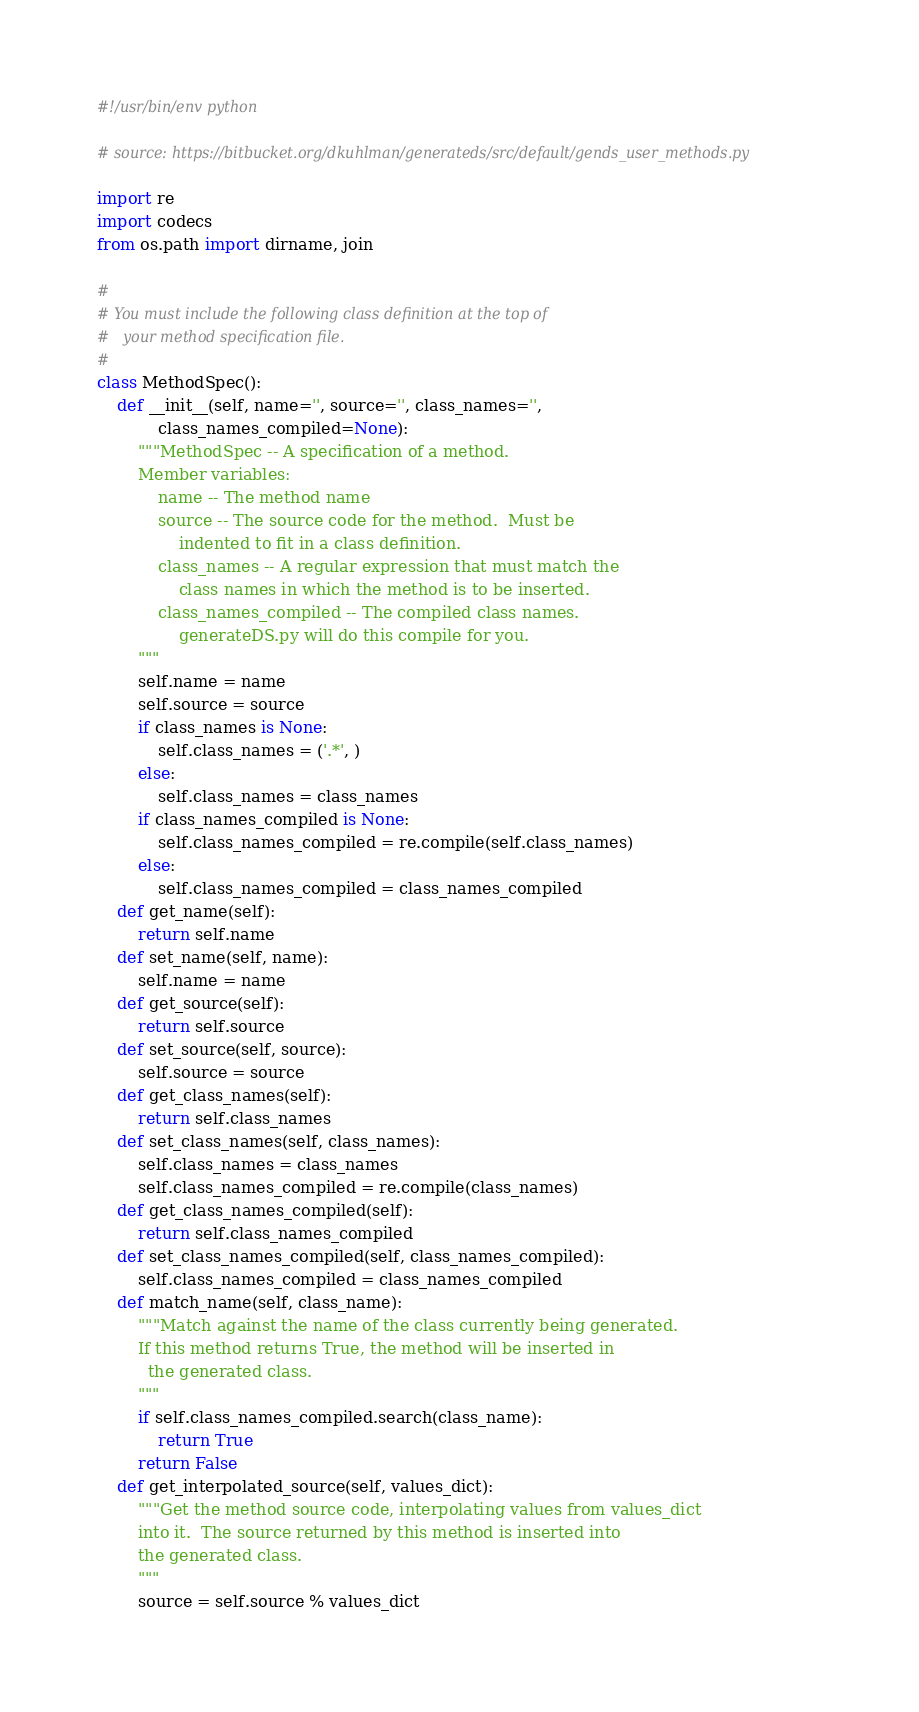<code> <loc_0><loc_0><loc_500><loc_500><_Python_>#!/usr/bin/env python

# source: https://bitbucket.org/dkuhlman/generateds/src/default/gends_user_methods.py

import re
import codecs
from os.path import dirname, join

#
# You must include the following class definition at the top of
#   your method specification file.
#
class MethodSpec():
    def __init__(self, name='', source='', class_names='',
            class_names_compiled=None):
        """MethodSpec -- A specification of a method.
        Member variables:
            name -- The method name
            source -- The source code for the method.  Must be
                indented to fit in a class definition.
            class_names -- A regular expression that must match the
                class names in which the method is to be inserted.
            class_names_compiled -- The compiled class names.
                generateDS.py will do this compile for you.
        """
        self.name = name
        self.source = source
        if class_names is None:
            self.class_names = ('.*', )
        else:
            self.class_names = class_names
        if class_names_compiled is None:
            self.class_names_compiled = re.compile(self.class_names)
        else:
            self.class_names_compiled = class_names_compiled
    def get_name(self):
        return self.name
    def set_name(self, name):
        self.name = name
    def get_source(self):
        return self.source
    def set_source(self, source):
        self.source = source
    def get_class_names(self):
        return self.class_names
    def set_class_names(self, class_names):
        self.class_names = class_names
        self.class_names_compiled = re.compile(class_names)
    def get_class_names_compiled(self):
        return self.class_names_compiled
    def set_class_names_compiled(self, class_names_compiled):
        self.class_names_compiled = class_names_compiled
    def match_name(self, class_name):
        """Match against the name of the class currently being generated.
        If this method returns True, the method will be inserted in
          the generated class.
        """
        if self.class_names_compiled.search(class_name):
            return True
        return False
    def get_interpolated_source(self, values_dict):
        """Get the method source code, interpolating values from values_dict
        into it.  The source returned by this method is inserted into
        the generated class.
        """
        source = self.source % values_dict</code> 